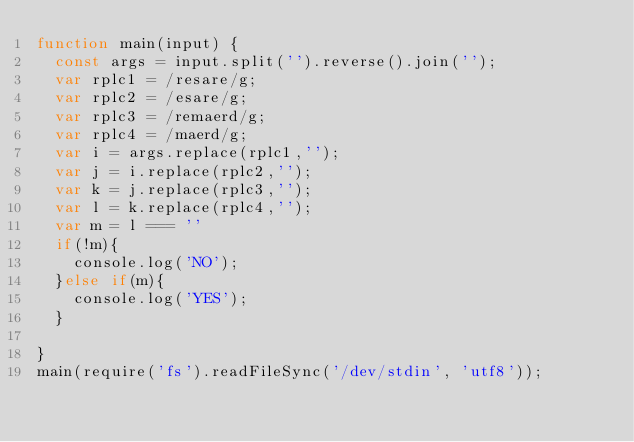<code> <loc_0><loc_0><loc_500><loc_500><_JavaScript_>function main(input) {
  const args = input.split('').reverse().join('');
  var rplc1 = /resare/g;
  var rplc2 = /esare/g;
  var rplc3 = /remaerd/g;
  var rplc4 = /maerd/g;
  var i = args.replace(rplc1,'');
  var j = i.replace(rplc2,'');
  var k = j.replace(rplc3,'');
  var l = k.replace(rplc4,'');
  var m = l === ''
  if(!m){
    console.log('NO');
  }else if(m){
    console.log('YES');
  }
  
}
main(require('fs').readFileSync('/dev/stdin', 'utf8'));</code> 